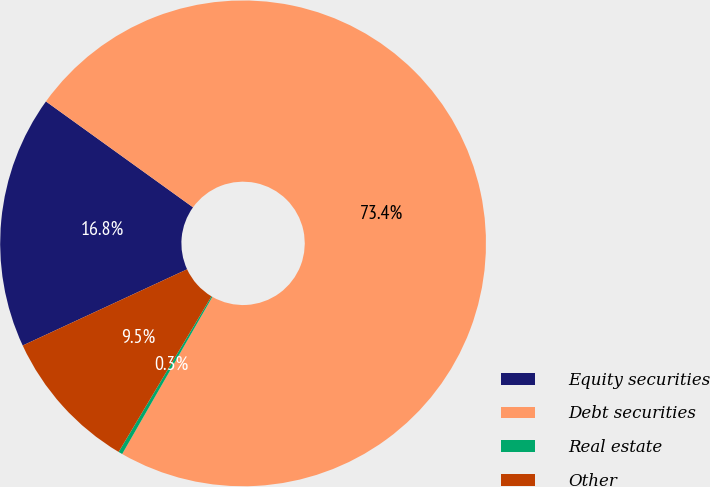Convert chart. <chart><loc_0><loc_0><loc_500><loc_500><pie_chart><fcel>Equity securities<fcel>Debt securities<fcel>Real estate<fcel>Other<nl><fcel>16.84%<fcel>73.36%<fcel>0.27%<fcel>9.53%<nl></chart> 